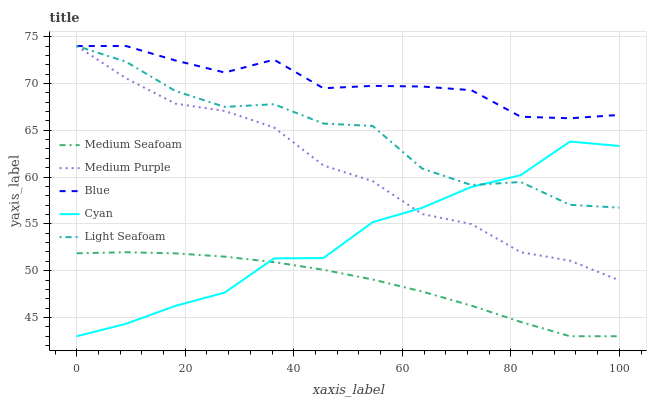Does Medium Seafoam have the minimum area under the curve?
Answer yes or no. Yes. Does Blue have the maximum area under the curve?
Answer yes or no. Yes. Does Light Seafoam have the minimum area under the curve?
Answer yes or no. No. Does Light Seafoam have the maximum area under the curve?
Answer yes or no. No. Is Medium Seafoam the smoothest?
Answer yes or no. Yes. Is Light Seafoam the roughest?
Answer yes or no. Yes. Is Blue the smoothest?
Answer yes or no. No. Is Blue the roughest?
Answer yes or no. No. Does Medium Seafoam have the lowest value?
Answer yes or no. Yes. Does Light Seafoam have the lowest value?
Answer yes or no. No. Does Light Seafoam have the highest value?
Answer yes or no. Yes. Does Medium Seafoam have the highest value?
Answer yes or no. No. Is Cyan less than Blue?
Answer yes or no. Yes. Is Blue greater than Medium Seafoam?
Answer yes or no. Yes. Does Light Seafoam intersect Blue?
Answer yes or no. Yes. Is Light Seafoam less than Blue?
Answer yes or no. No. Is Light Seafoam greater than Blue?
Answer yes or no. No. Does Cyan intersect Blue?
Answer yes or no. No. 